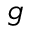<formula> <loc_0><loc_0><loc_500><loc_500>g</formula> 